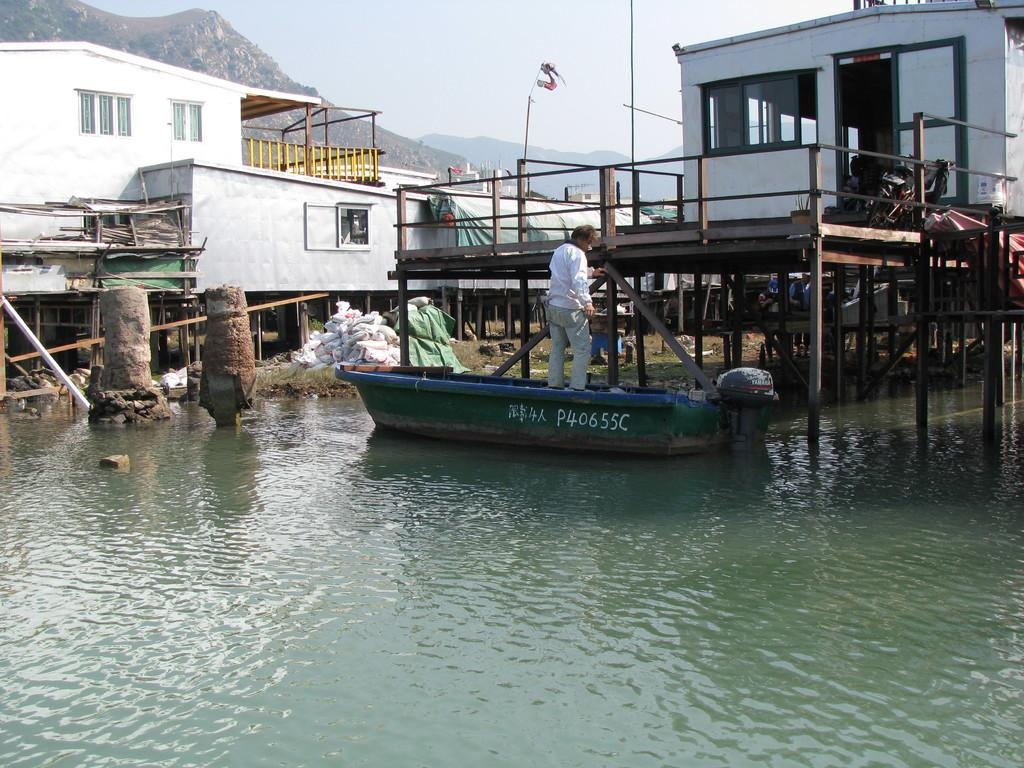What is the unusual feature of the houses in the image? The houses are located on a bridge in the image. What is the person on the boat doing? The person is standing on a boat in the image. What can be seen through the windows in the image? The windows in the image provide a view of the surrounding environment, including mountains and water. What type of structures are present in the image? Poles are present in the image. What items are visible in the image? Bags are visible in the image. What is the primary body of water in the image? There is water in the image. What is the color of the sky in the image? The sky is blue in the image. What type of butter is being spread on the train tracks in the image? There is no butter or train tracks present in the image. How does the person's anger affect the houses on the bridge in the image? There is no indication of anger or its effects on the houses in the image. 